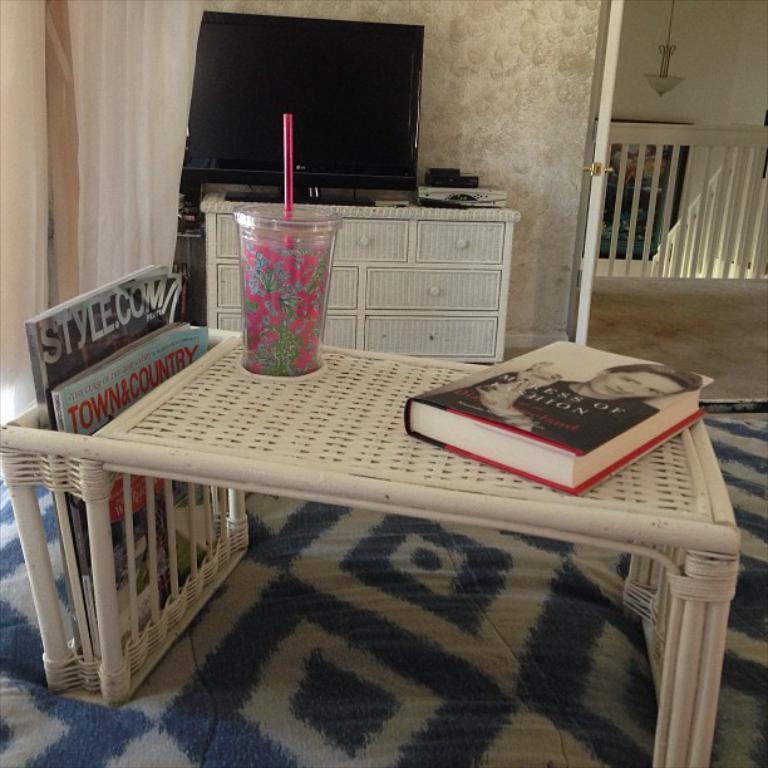How would you summarize this image in a sentence or two? This picture is clicked in a room. In the center there is a table, behind it there is a desk, on the desk there is a television. On the table there are some books and a glass. Towards the right top there is a door. 